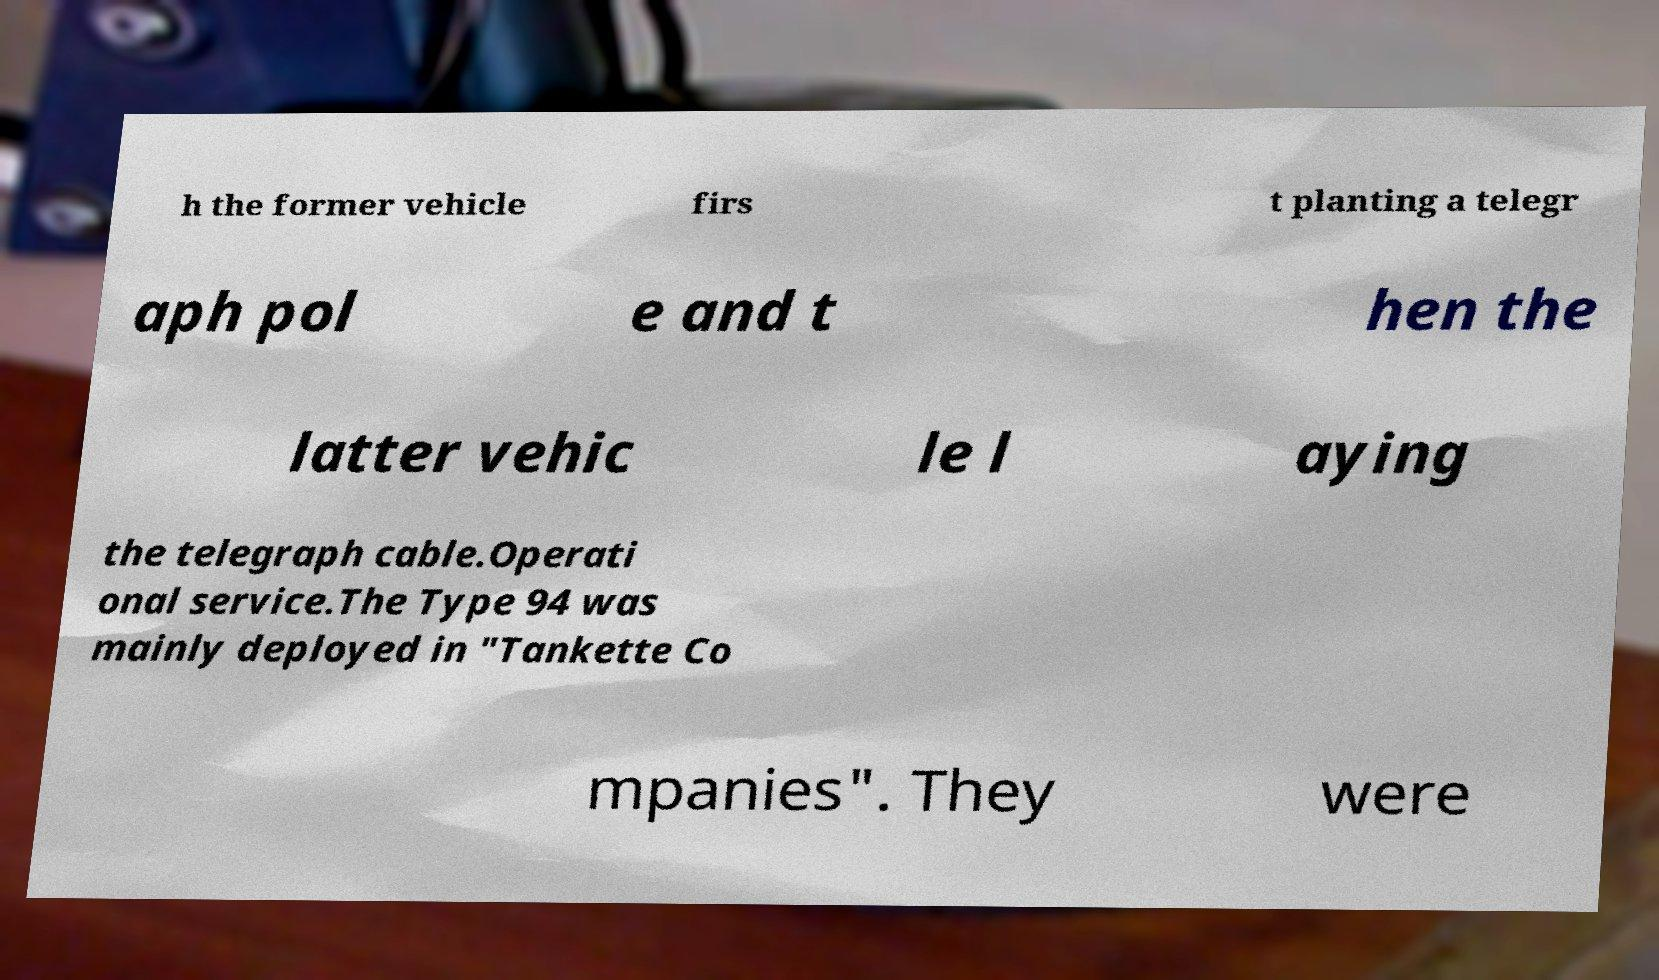Can you accurately transcribe the text from the provided image for me? h the former vehicle firs t planting a telegr aph pol e and t hen the latter vehic le l aying the telegraph cable.Operati onal service.The Type 94 was mainly deployed in "Tankette Co mpanies". They were 